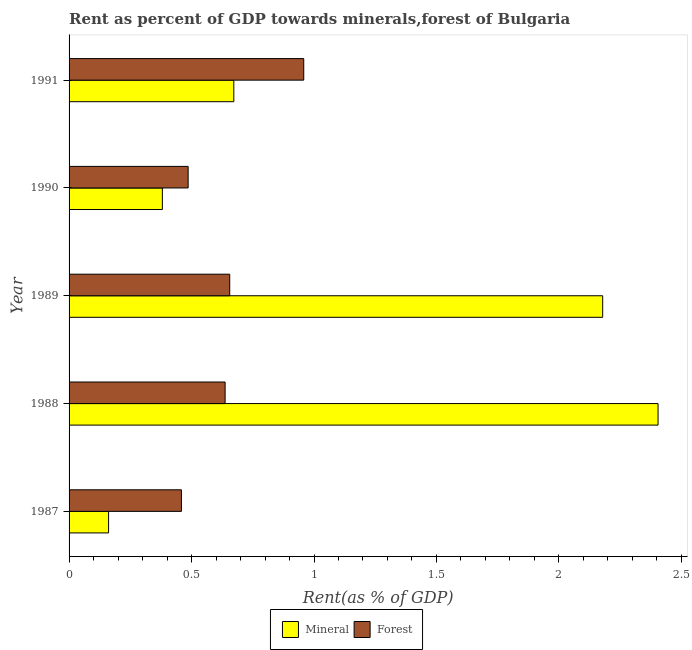Are the number of bars on each tick of the Y-axis equal?
Provide a succinct answer. Yes. How many bars are there on the 1st tick from the bottom?
Provide a short and direct response. 2. In how many cases, is the number of bars for a given year not equal to the number of legend labels?
Offer a very short reply. 0. What is the forest rent in 1991?
Your response must be concise. 0.96. Across all years, what is the maximum mineral rent?
Make the answer very short. 2.4. Across all years, what is the minimum forest rent?
Your answer should be very brief. 0.46. In which year was the forest rent maximum?
Offer a very short reply. 1991. In which year was the forest rent minimum?
Provide a succinct answer. 1987. What is the total mineral rent in the graph?
Your answer should be very brief. 5.8. What is the difference between the mineral rent in 1987 and that in 1989?
Offer a terse response. -2.02. What is the difference between the forest rent in 1987 and the mineral rent in 1990?
Provide a short and direct response. 0.08. What is the average mineral rent per year?
Offer a terse response. 1.16. In the year 1990, what is the difference between the mineral rent and forest rent?
Your answer should be very brief. -0.1. In how many years, is the forest rent greater than 1.4 %?
Your response must be concise. 0. What is the ratio of the forest rent in 1987 to that in 1990?
Provide a short and direct response. 0.94. Is the forest rent in 1987 less than that in 1991?
Offer a terse response. Yes. What is the difference between the highest and the second highest forest rent?
Offer a very short reply. 0.3. What is the difference between the highest and the lowest forest rent?
Give a very brief answer. 0.5. In how many years, is the forest rent greater than the average forest rent taken over all years?
Make the answer very short. 2. Is the sum of the mineral rent in 1987 and 1991 greater than the maximum forest rent across all years?
Your answer should be very brief. No. What does the 1st bar from the top in 1989 represents?
Your answer should be very brief. Forest. What does the 1st bar from the bottom in 1990 represents?
Give a very brief answer. Mineral. How many bars are there?
Ensure brevity in your answer.  10. Are all the bars in the graph horizontal?
Your answer should be very brief. Yes. How many years are there in the graph?
Provide a short and direct response. 5. What is the difference between two consecutive major ticks on the X-axis?
Your answer should be compact. 0.5. Are the values on the major ticks of X-axis written in scientific E-notation?
Keep it short and to the point. No. Where does the legend appear in the graph?
Offer a terse response. Bottom center. How many legend labels are there?
Make the answer very short. 2. What is the title of the graph?
Provide a succinct answer. Rent as percent of GDP towards minerals,forest of Bulgaria. Does "Non-solid fuel" appear as one of the legend labels in the graph?
Give a very brief answer. No. What is the label or title of the X-axis?
Offer a very short reply. Rent(as % of GDP). What is the label or title of the Y-axis?
Ensure brevity in your answer.  Year. What is the Rent(as % of GDP) of Mineral in 1987?
Offer a very short reply. 0.16. What is the Rent(as % of GDP) of Forest in 1987?
Your answer should be compact. 0.46. What is the Rent(as % of GDP) in Mineral in 1988?
Your answer should be very brief. 2.4. What is the Rent(as % of GDP) in Forest in 1988?
Provide a succinct answer. 0.64. What is the Rent(as % of GDP) in Mineral in 1989?
Ensure brevity in your answer.  2.18. What is the Rent(as % of GDP) in Forest in 1989?
Offer a very short reply. 0.66. What is the Rent(as % of GDP) of Mineral in 1990?
Keep it short and to the point. 0.38. What is the Rent(as % of GDP) of Forest in 1990?
Your answer should be very brief. 0.49. What is the Rent(as % of GDP) in Mineral in 1991?
Your response must be concise. 0.67. What is the Rent(as % of GDP) of Forest in 1991?
Give a very brief answer. 0.96. Across all years, what is the maximum Rent(as % of GDP) of Mineral?
Provide a succinct answer. 2.4. Across all years, what is the maximum Rent(as % of GDP) in Forest?
Make the answer very short. 0.96. Across all years, what is the minimum Rent(as % of GDP) of Mineral?
Your answer should be very brief. 0.16. Across all years, what is the minimum Rent(as % of GDP) of Forest?
Ensure brevity in your answer.  0.46. What is the total Rent(as % of GDP) in Mineral in the graph?
Provide a succinct answer. 5.8. What is the total Rent(as % of GDP) in Forest in the graph?
Ensure brevity in your answer.  3.2. What is the difference between the Rent(as % of GDP) of Mineral in 1987 and that in 1988?
Provide a short and direct response. -2.24. What is the difference between the Rent(as % of GDP) in Forest in 1987 and that in 1988?
Your response must be concise. -0.18. What is the difference between the Rent(as % of GDP) in Mineral in 1987 and that in 1989?
Keep it short and to the point. -2.02. What is the difference between the Rent(as % of GDP) of Forest in 1987 and that in 1989?
Provide a short and direct response. -0.2. What is the difference between the Rent(as % of GDP) in Mineral in 1987 and that in 1990?
Keep it short and to the point. -0.22. What is the difference between the Rent(as % of GDP) in Forest in 1987 and that in 1990?
Keep it short and to the point. -0.03. What is the difference between the Rent(as % of GDP) of Mineral in 1987 and that in 1991?
Ensure brevity in your answer.  -0.51. What is the difference between the Rent(as % of GDP) in Forest in 1987 and that in 1991?
Give a very brief answer. -0.5. What is the difference between the Rent(as % of GDP) in Mineral in 1988 and that in 1989?
Provide a succinct answer. 0.23. What is the difference between the Rent(as % of GDP) in Forest in 1988 and that in 1989?
Provide a succinct answer. -0.02. What is the difference between the Rent(as % of GDP) of Mineral in 1988 and that in 1990?
Offer a very short reply. 2.02. What is the difference between the Rent(as % of GDP) in Forest in 1988 and that in 1990?
Provide a succinct answer. 0.15. What is the difference between the Rent(as % of GDP) of Mineral in 1988 and that in 1991?
Offer a very short reply. 1.73. What is the difference between the Rent(as % of GDP) in Forest in 1988 and that in 1991?
Keep it short and to the point. -0.32. What is the difference between the Rent(as % of GDP) in Mineral in 1989 and that in 1990?
Provide a succinct answer. 1.8. What is the difference between the Rent(as % of GDP) of Forest in 1989 and that in 1990?
Your response must be concise. 0.17. What is the difference between the Rent(as % of GDP) of Mineral in 1989 and that in 1991?
Give a very brief answer. 1.51. What is the difference between the Rent(as % of GDP) in Forest in 1989 and that in 1991?
Offer a terse response. -0.3. What is the difference between the Rent(as % of GDP) in Mineral in 1990 and that in 1991?
Give a very brief answer. -0.29. What is the difference between the Rent(as % of GDP) of Forest in 1990 and that in 1991?
Your answer should be compact. -0.47. What is the difference between the Rent(as % of GDP) in Mineral in 1987 and the Rent(as % of GDP) in Forest in 1988?
Offer a terse response. -0.48. What is the difference between the Rent(as % of GDP) in Mineral in 1987 and the Rent(as % of GDP) in Forest in 1989?
Provide a succinct answer. -0.49. What is the difference between the Rent(as % of GDP) in Mineral in 1987 and the Rent(as % of GDP) in Forest in 1990?
Your answer should be very brief. -0.32. What is the difference between the Rent(as % of GDP) of Mineral in 1987 and the Rent(as % of GDP) of Forest in 1991?
Your answer should be compact. -0.8. What is the difference between the Rent(as % of GDP) in Mineral in 1988 and the Rent(as % of GDP) in Forest in 1989?
Provide a short and direct response. 1.75. What is the difference between the Rent(as % of GDP) of Mineral in 1988 and the Rent(as % of GDP) of Forest in 1990?
Your answer should be very brief. 1.92. What is the difference between the Rent(as % of GDP) in Mineral in 1988 and the Rent(as % of GDP) in Forest in 1991?
Give a very brief answer. 1.45. What is the difference between the Rent(as % of GDP) of Mineral in 1989 and the Rent(as % of GDP) of Forest in 1990?
Offer a very short reply. 1.69. What is the difference between the Rent(as % of GDP) in Mineral in 1989 and the Rent(as % of GDP) in Forest in 1991?
Offer a very short reply. 1.22. What is the difference between the Rent(as % of GDP) in Mineral in 1990 and the Rent(as % of GDP) in Forest in 1991?
Your response must be concise. -0.58. What is the average Rent(as % of GDP) of Mineral per year?
Provide a short and direct response. 1.16. What is the average Rent(as % of GDP) in Forest per year?
Ensure brevity in your answer.  0.64. In the year 1987, what is the difference between the Rent(as % of GDP) in Mineral and Rent(as % of GDP) in Forest?
Make the answer very short. -0.3. In the year 1988, what is the difference between the Rent(as % of GDP) in Mineral and Rent(as % of GDP) in Forest?
Provide a short and direct response. 1.77. In the year 1989, what is the difference between the Rent(as % of GDP) of Mineral and Rent(as % of GDP) of Forest?
Offer a terse response. 1.52. In the year 1990, what is the difference between the Rent(as % of GDP) in Mineral and Rent(as % of GDP) in Forest?
Make the answer very short. -0.11. In the year 1991, what is the difference between the Rent(as % of GDP) in Mineral and Rent(as % of GDP) in Forest?
Ensure brevity in your answer.  -0.29. What is the ratio of the Rent(as % of GDP) in Mineral in 1987 to that in 1988?
Offer a very short reply. 0.07. What is the ratio of the Rent(as % of GDP) in Forest in 1987 to that in 1988?
Give a very brief answer. 0.72. What is the ratio of the Rent(as % of GDP) of Mineral in 1987 to that in 1989?
Give a very brief answer. 0.07. What is the ratio of the Rent(as % of GDP) in Forest in 1987 to that in 1989?
Ensure brevity in your answer.  0.7. What is the ratio of the Rent(as % of GDP) in Mineral in 1987 to that in 1990?
Your response must be concise. 0.42. What is the ratio of the Rent(as % of GDP) of Forest in 1987 to that in 1990?
Ensure brevity in your answer.  0.94. What is the ratio of the Rent(as % of GDP) of Mineral in 1987 to that in 1991?
Make the answer very short. 0.24. What is the ratio of the Rent(as % of GDP) of Forest in 1987 to that in 1991?
Offer a very short reply. 0.48. What is the ratio of the Rent(as % of GDP) in Mineral in 1988 to that in 1989?
Your answer should be compact. 1.1. What is the ratio of the Rent(as % of GDP) of Forest in 1988 to that in 1989?
Ensure brevity in your answer.  0.97. What is the ratio of the Rent(as % of GDP) in Mineral in 1988 to that in 1990?
Offer a terse response. 6.31. What is the ratio of the Rent(as % of GDP) in Forest in 1988 to that in 1990?
Ensure brevity in your answer.  1.31. What is the ratio of the Rent(as % of GDP) of Mineral in 1988 to that in 1991?
Give a very brief answer. 3.58. What is the ratio of the Rent(as % of GDP) of Forest in 1988 to that in 1991?
Offer a terse response. 0.66. What is the ratio of the Rent(as % of GDP) in Mineral in 1989 to that in 1990?
Your answer should be very brief. 5.72. What is the ratio of the Rent(as % of GDP) of Forest in 1989 to that in 1990?
Ensure brevity in your answer.  1.35. What is the ratio of the Rent(as % of GDP) of Mineral in 1989 to that in 1991?
Offer a very short reply. 3.24. What is the ratio of the Rent(as % of GDP) in Forest in 1989 to that in 1991?
Your response must be concise. 0.68. What is the ratio of the Rent(as % of GDP) in Mineral in 1990 to that in 1991?
Offer a very short reply. 0.57. What is the ratio of the Rent(as % of GDP) of Forest in 1990 to that in 1991?
Make the answer very short. 0.51. What is the difference between the highest and the second highest Rent(as % of GDP) in Mineral?
Your answer should be very brief. 0.23. What is the difference between the highest and the second highest Rent(as % of GDP) in Forest?
Your answer should be compact. 0.3. What is the difference between the highest and the lowest Rent(as % of GDP) of Mineral?
Provide a short and direct response. 2.24. What is the difference between the highest and the lowest Rent(as % of GDP) of Forest?
Provide a short and direct response. 0.5. 